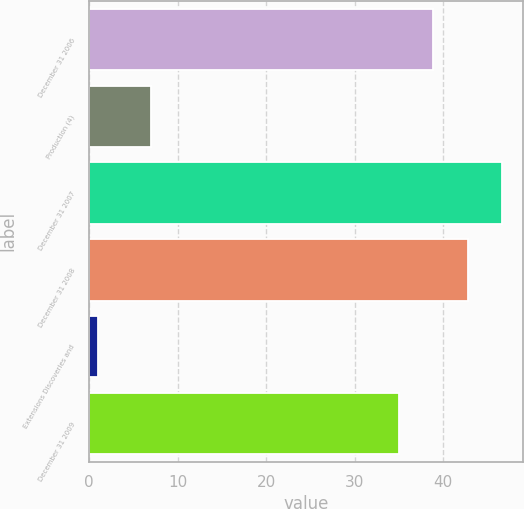Convert chart to OTSL. <chart><loc_0><loc_0><loc_500><loc_500><bar_chart><fcel>December 31 2006<fcel>Production (4)<fcel>December 31 2007<fcel>December 31 2008<fcel>Extensions Discoveries and<fcel>December 31 2009<nl><fcel>38.9<fcel>7<fcel>46.7<fcel>42.8<fcel>1<fcel>35<nl></chart> 